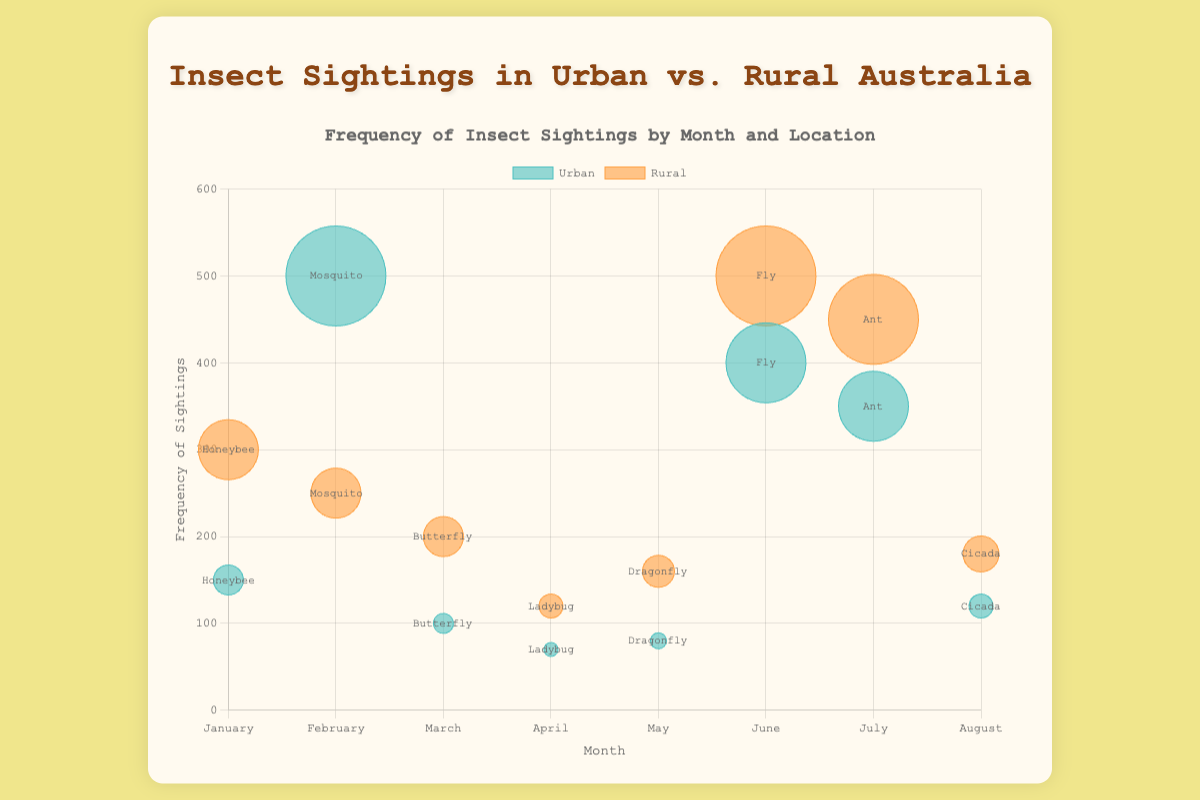How many insect sightings are reported in total for Mosquitoes in both Urban and Rural areas for February? First, look at the data points labeled as "Mosquito" for February. The frequency in Urban areas is 500, and in Rural areas, it is 250. Add these together to get 500 + 250 = 750 sightings.
Answer: 750 Which insect sighting has the highest frequency in Rural areas? Check the data points for Rural locations and compare their frequencies. The Fly in Rural areas during June has the highest frequency of 500.
Answer: Fly What is the month with the highest frequency of Fly sightings in Urban areas? Look for the Fly data points in Urban areas and note their frequencies. The highest urban Fly sighting frequency is 400, and it occurs in June.
Answer: June Are there more Honeybee sightings in January in Urban or Rural areas? Compare the Honeybee frequency in Urban areas (150) to the frequency in Rural areas (300) in January. Rural areas have more sightings.
Answer: Rural What is the average frequency of Butterfly sightings across both Urban and Rural areas in March? Find the Butterfly data points for Urban and Rural areas in March. The frequency in Urban areas is 100, and in Rural areas is 200. Calculate the average by summing these values and dividing by 2. The average is (100 + 200) / 2 = 150.
Answer: 150 Which insect has the lowest frequency of sightings in Urban areas, and in what month? Look for the data points with the lowest frequency value in Urban areas. The Ladybug in Urban areas during April has the lowest frequency of 70.
Answer: Ladybug How does the frequency of Ant sightings compare between Urban and Rural areas in July? Check the data points for Ant in July. The frequency is 350 in Urban areas and 450 in Rural areas. Rural areas have 100 more sightings.
Answer: More in Rural What is the difference between the maximum and minimum frequency of insect sightings for any insect in Urban areas? Find the maximum and minimum frequency values for all Urban insects. The maximum is 500 (Mosquito in February) and the minimum is 70 (Ladybug in April). The difference is 500 - 70 = 430.
Answer: 430 What are the frequencies of Cicada sightings in Urban and Rural areas in August? Locate the data points for Cicada in August. The frequency is 120 in Urban areas and 180 in Rural areas.
Answer: 120 and 180 Which insect sighting shows a larger size bubble in Urban areas compared to Rural areas in May? Look at the data points for May and compare the bubble sizes. The bubble size is determined by frequency. Dragonflies in May have a larger bubble in Rural areas (160) compared to Urban areas (80).
Answer: No insect 